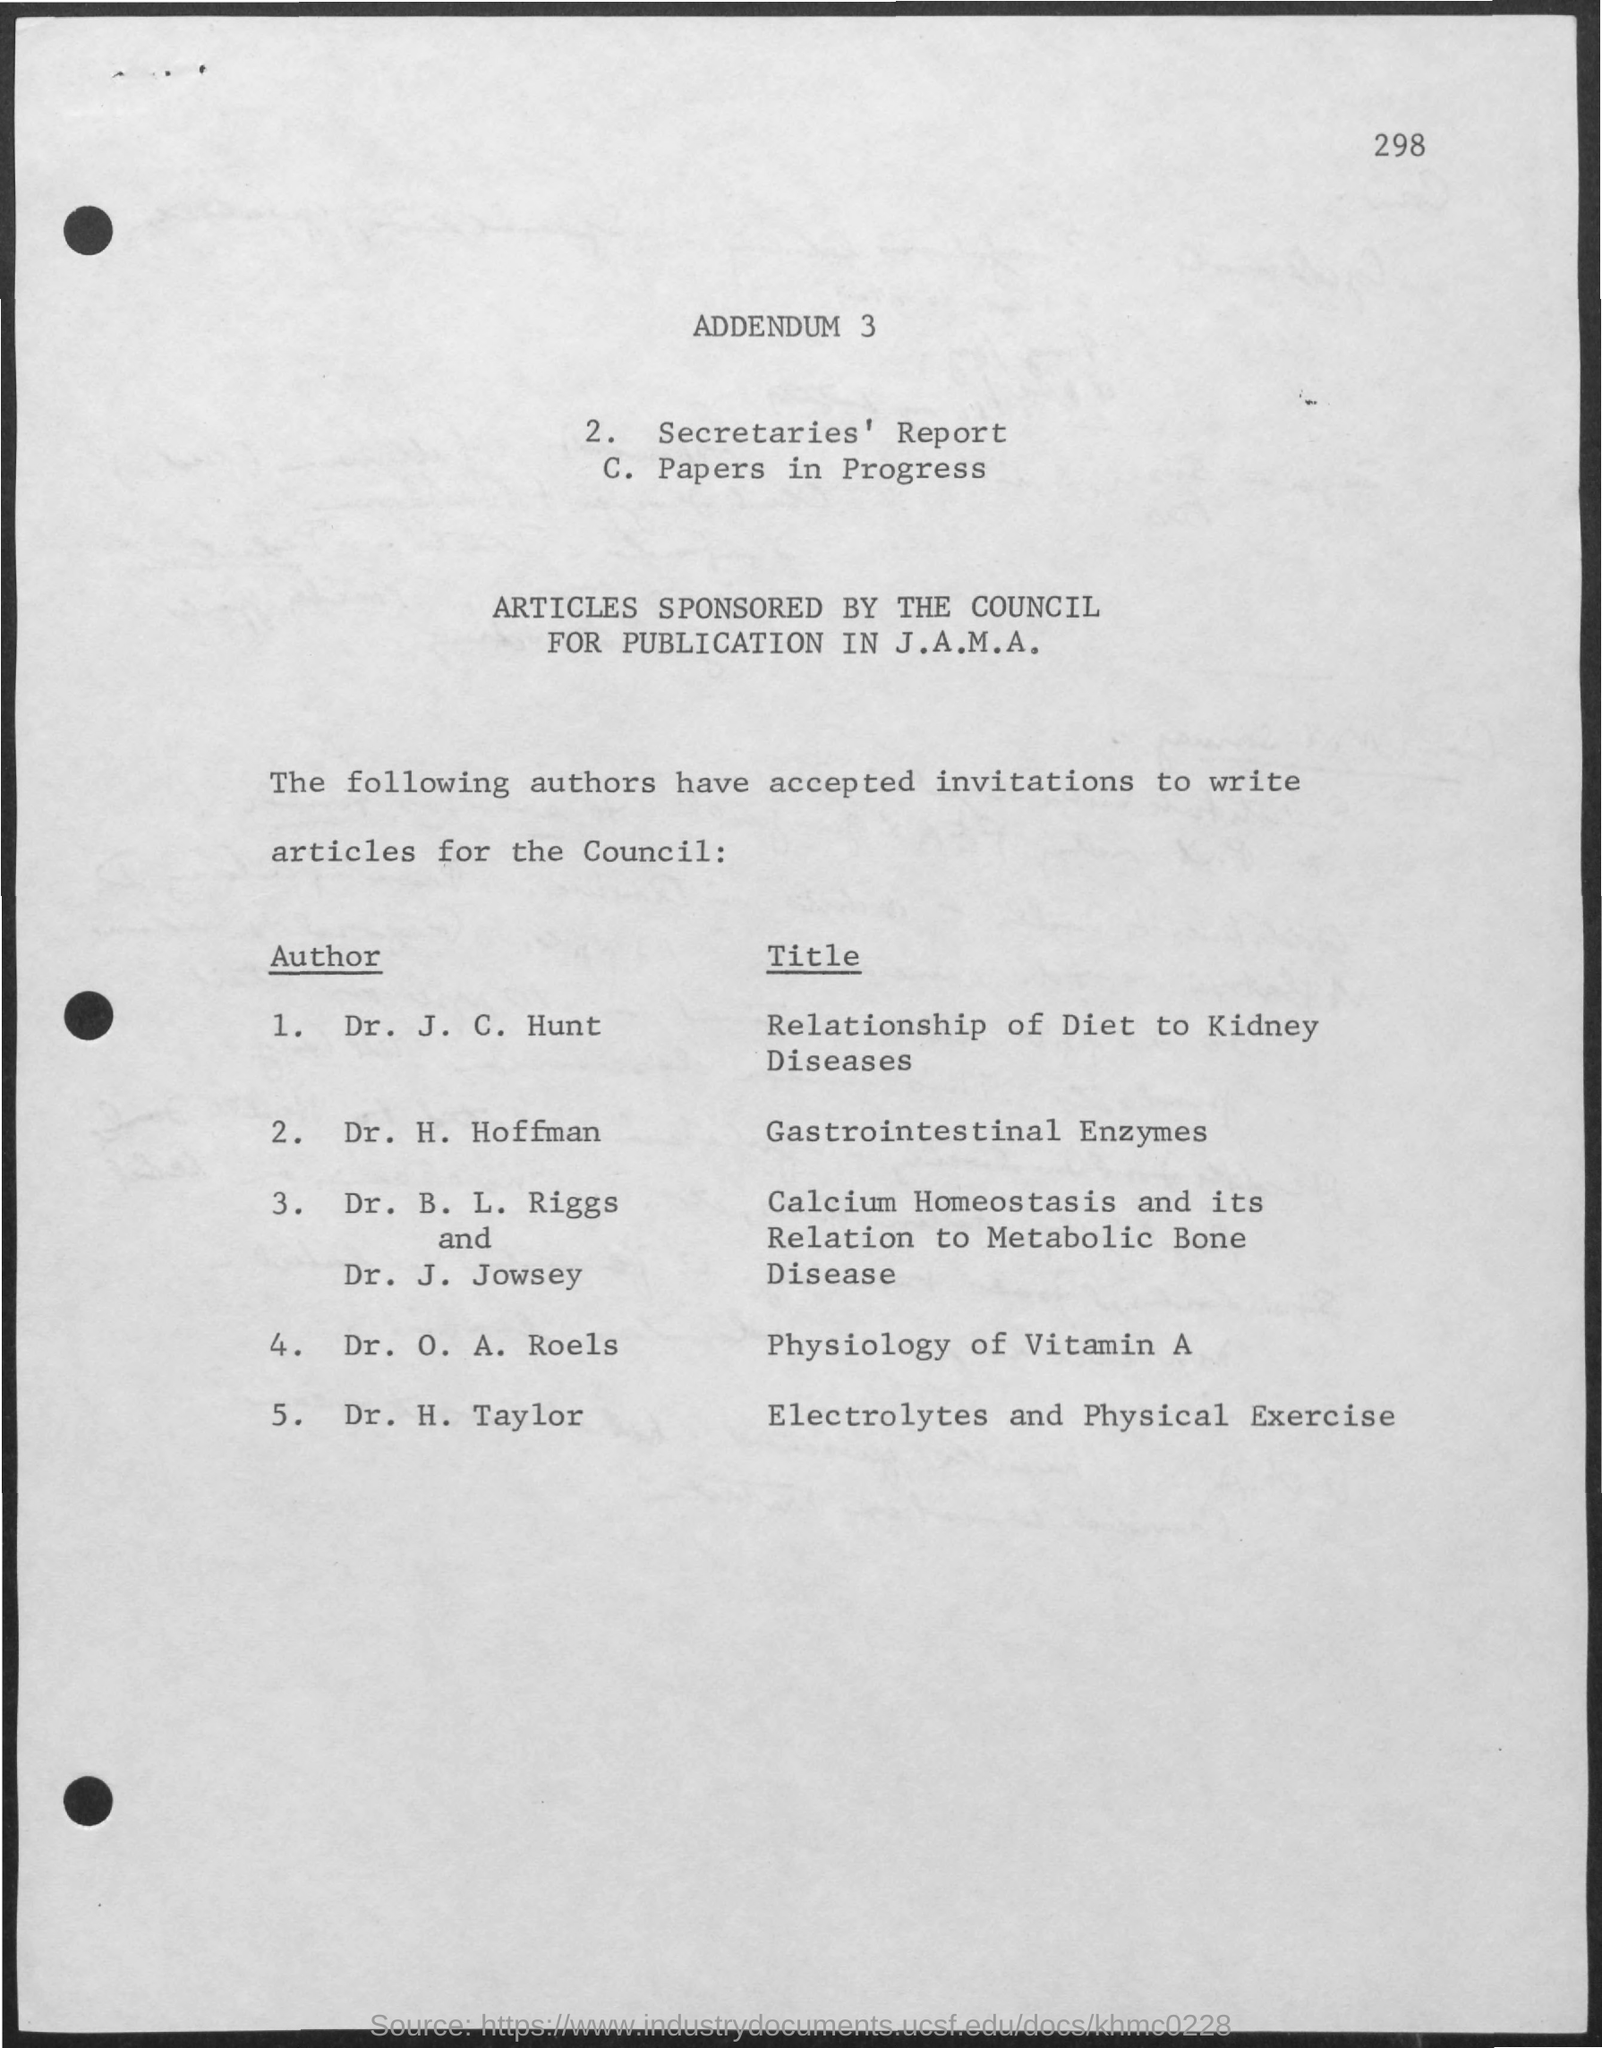List a handful of essential elements in this visual. The author of "Physiology of Vitamin A" is Dr. O.A. Roels. The author of "Gastrointestinal Enzymes," also known as Dr. H. Hoffman, is a respected expert in the field of gastrointestinal health. 